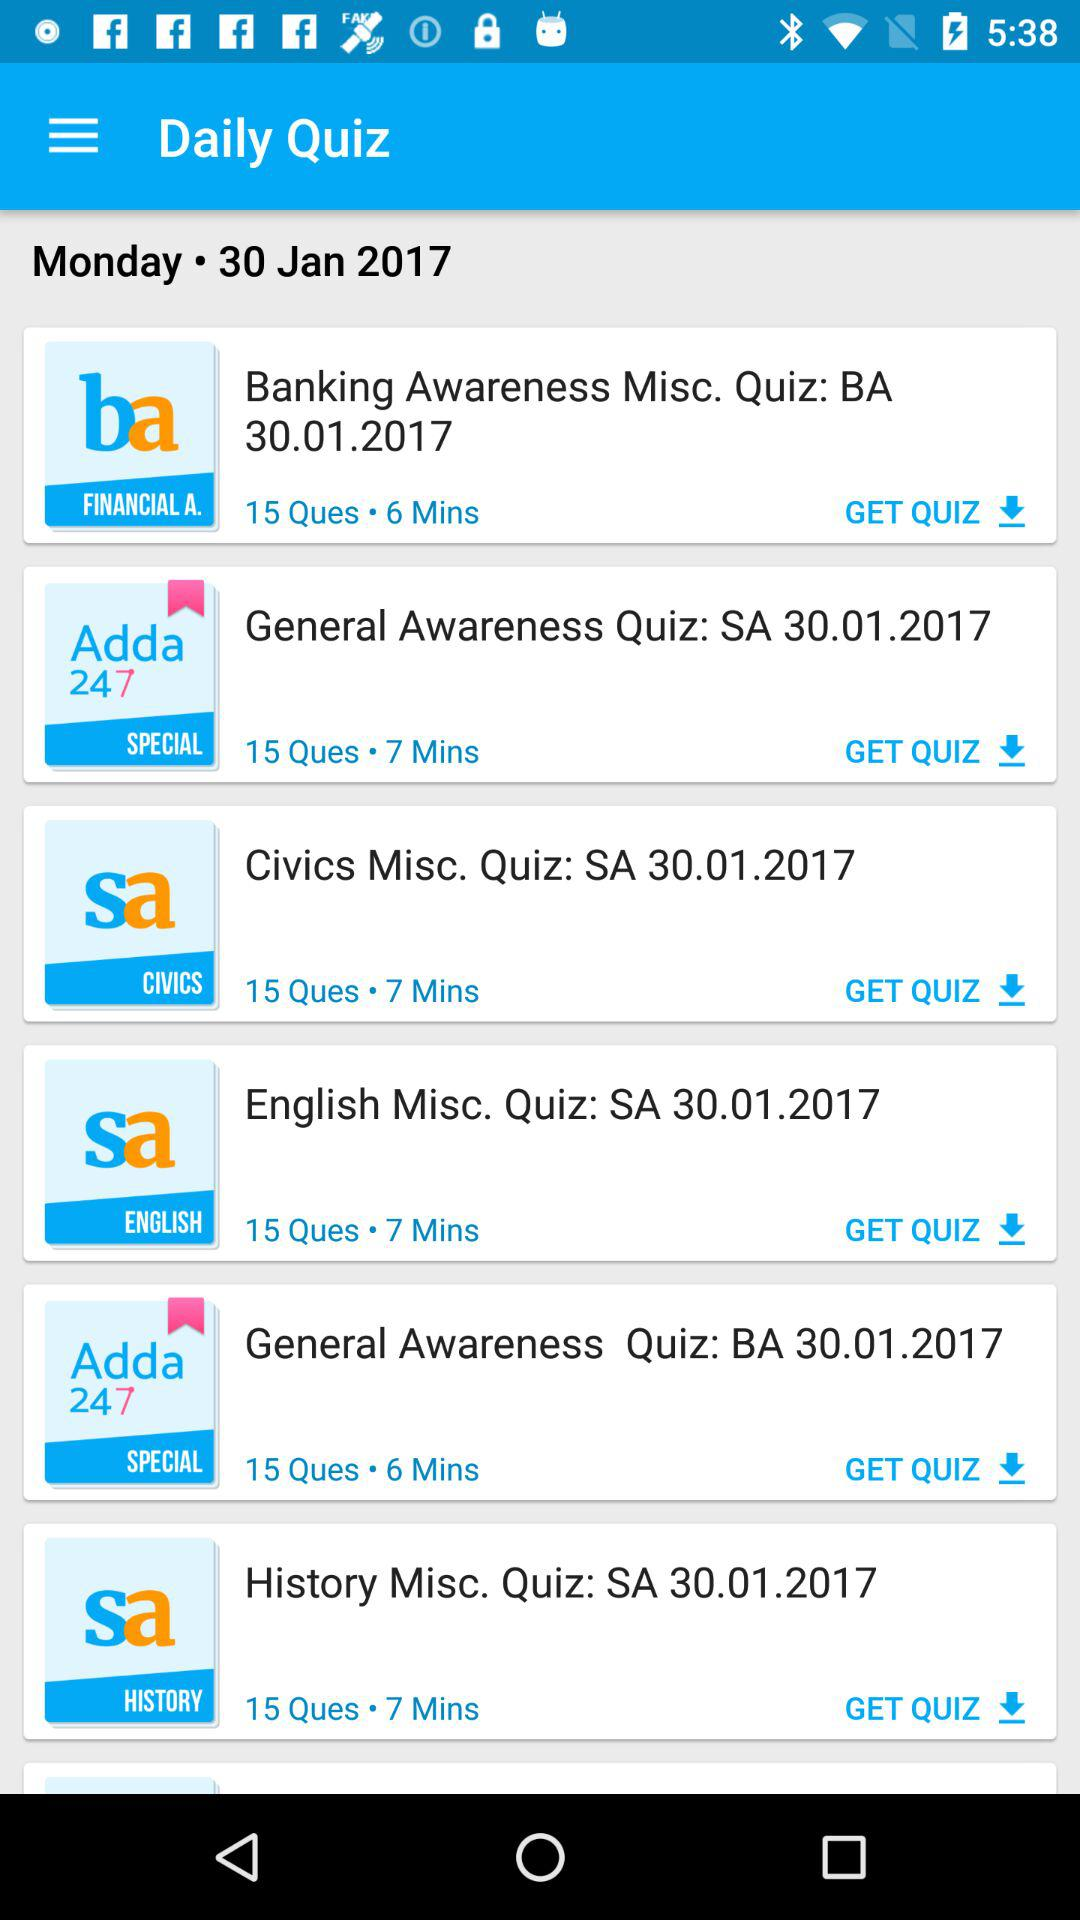What is the publication day and date? The publication day and date are Monday and January 30, 2017, respectively. 